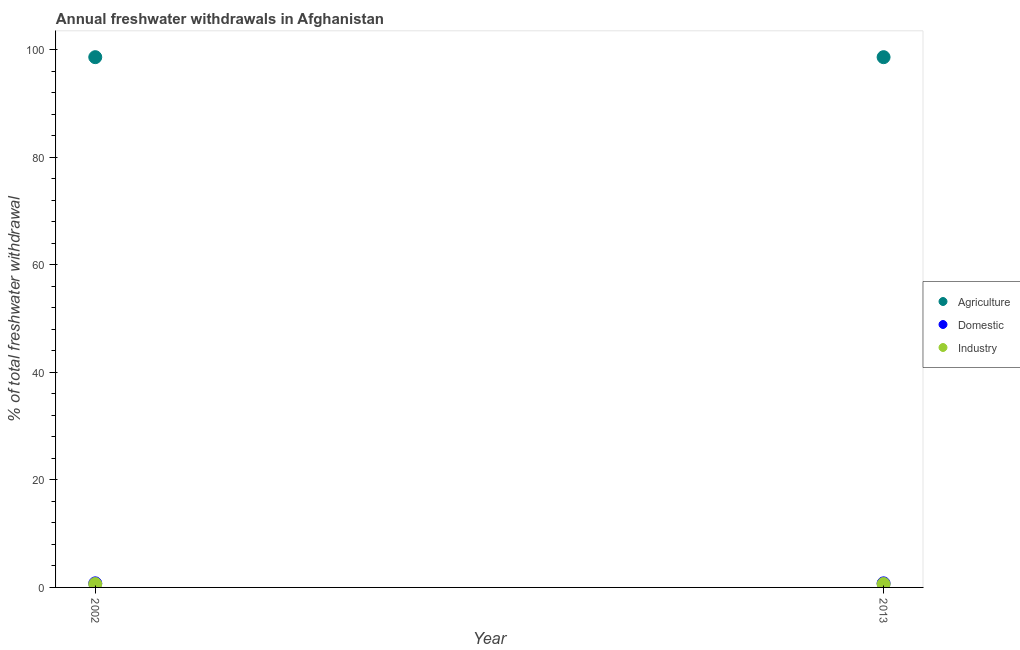Is the number of dotlines equal to the number of legend labels?
Your response must be concise. Yes. What is the percentage of freshwater withdrawal for domestic purposes in 2013?
Make the answer very short. 0.76. Across all years, what is the maximum percentage of freshwater withdrawal for domestic purposes?
Offer a terse response. 0.76. Across all years, what is the minimum percentage of freshwater withdrawal for industry?
Provide a short and direct response. 0.63. What is the total percentage of freshwater withdrawal for domestic purposes in the graph?
Offer a terse response. 1.52. What is the difference between the percentage of freshwater withdrawal for domestic purposes in 2002 and that in 2013?
Keep it short and to the point. 0. What is the difference between the percentage of freshwater withdrawal for domestic purposes in 2013 and the percentage of freshwater withdrawal for agriculture in 2002?
Offer a terse response. -97.86. What is the average percentage of freshwater withdrawal for agriculture per year?
Your answer should be compact. 98.62. In the year 2013, what is the difference between the percentage of freshwater withdrawal for industry and percentage of freshwater withdrawal for domestic purposes?
Offer a very short reply. -0.13. What is the ratio of the percentage of freshwater withdrawal for domestic purposes in 2002 to that in 2013?
Offer a terse response. 1. Is the percentage of freshwater withdrawal for agriculture in 2002 less than that in 2013?
Offer a very short reply. No. In how many years, is the percentage of freshwater withdrawal for agriculture greater than the average percentage of freshwater withdrawal for agriculture taken over all years?
Offer a terse response. 0. Is it the case that in every year, the sum of the percentage of freshwater withdrawal for agriculture and percentage of freshwater withdrawal for domestic purposes is greater than the percentage of freshwater withdrawal for industry?
Your answer should be very brief. Yes. Does the percentage of freshwater withdrawal for industry monotonically increase over the years?
Your answer should be compact. No. Is the percentage of freshwater withdrawal for agriculture strictly greater than the percentage of freshwater withdrawal for domestic purposes over the years?
Make the answer very short. Yes. Is the percentage of freshwater withdrawal for domestic purposes strictly less than the percentage of freshwater withdrawal for industry over the years?
Your answer should be compact. No. How many dotlines are there?
Give a very brief answer. 3. How many years are there in the graph?
Offer a very short reply. 2. What is the difference between two consecutive major ticks on the Y-axis?
Your answer should be compact. 20. Where does the legend appear in the graph?
Make the answer very short. Center right. How are the legend labels stacked?
Your response must be concise. Vertical. What is the title of the graph?
Offer a very short reply. Annual freshwater withdrawals in Afghanistan. Does "New Zealand" appear as one of the legend labels in the graph?
Offer a terse response. No. What is the label or title of the Y-axis?
Make the answer very short. % of total freshwater withdrawal. What is the % of total freshwater withdrawal in Agriculture in 2002?
Your answer should be very brief. 98.62. What is the % of total freshwater withdrawal in Domestic in 2002?
Keep it short and to the point. 0.76. What is the % of total freshwater withdrawal in Industry in 2002?
Your answer should be compact. 0.63. What is the % of total freshwater withdrawal in Agriculture in 2013?
Provide a short and direct response. 98.62. What is the % of total freshwater withdrawal in Domestic in 2013?
Ensure brevity in your answer.  0.76. What is the % of total freshwater withdrawal in Industry in 2013?
Give a very brief answer. 0.63. Across all years, what is the maximum % of total freshwater withdrawal in Agriculture?
Keep it short and to the point. 98.62. Across all years, what is the maximum % of total freshwater withdrawal in Domestic?
Make the answer very short. 0.76. Across all years, what is the maximum % of total freshwater withdrawal of Industry?
Your response must be concise. 0.63. Across all years, what is the minimum % of total freshwater withdrawal in Agriculture?
Your response must be concise. 98.62. Across all years, what is the minimum % of total freshwater withdrawal in Domestic?
Offer a very short reply. 0.76. Across all years, what is the minimum % of total freshwater withdrawal of Industry?
Your response must be concise. 0.63. What is the total % of total freshwater withdrawal of Agriculture in the graph?
Offer a very short reply. 197.24. What is the total % of total freshwater withdrawal in Domestic in the graph?
Offer a very short reply. 1.52. What is the total % of total freshwater withdrawal in Industry in the graph?
Your answer should be compact. 1.27. What is the difference between the % of total freshwater withdrawal of Domestic in 2002 and that in 2013?
Your answer should be very brief. 0. What is the difference between the % of total freshwater withdrawal of Agriculture in 2002 and the % of total freshwater withdrawal of Domestic in 2013?
Your answer should be very brief. 97.86. What is the difference between the % of total freshwater withdrawal in Agriculture in 2002 and the % of total freshwater withdrawal in Industry in 2013?
Provide a short and direct response. 97.99. What is the difference between the % of total freshwater withdrawal of Domestic in 2002 and the % of total freshwater withdrawal of Industry in 2013?
Your answer should be compact. 0.13. What is the average % of total freshwater withdrawal in Agriculture per year?
Your response must be concise. 98.62. What is the average % of total freshwater withdrawal of Domestic per year?
Your answer should be compact. 0.76. What is the average % of total freshwater withdrawal of Industry per year?
Offer a terse response. 0.63. In the year 2002, what is the difference between the % of total freshwater withdrawal in Agriculture and % of total freshwater withdrawal in Domestic?
Your response must be concise. 97.86. In the year 2002, what is the difference between the % of total freshwater withdrawal in Agriculture and % of total freshwater withdrawal in Industry?
Keep it short and to the point. 97.99. In the year 2002, what is the difference between the % of total freshwater withdrawal in Domestic and % of total freshwater withdrawal in Industry?
Your answer should be compact. 0.13. In the year 2013, what is the difference between the % of total freshwater withdrawal of Agriculture and % of total freshwater withdrawal of Domestic?
Keep it short and to the point. 97.86. In the year 2013, what is the difference between the % of total freshwater withdrawal in Agriculture and % of total freshwater withdrawal in Industry?
Provide a short and direct response. 97.99. In the year 2013, what is the difference between the % of total freshwater withdrawal in Domestic and % of total freshwater withdrawal in Industry?
Keep it short and to the point. 0.13. What is the ratio of the % of total freshwater withdrawal of Agriculture in 2002 to that in 2013?
Offer a terse response. 1. What is the ratio of the % of total freshwater withdrawal in Domestic in 2002 to that in 2013?
Make the answer very short. 1. What is the difference between the highest and the second highest % of total freshwater withdrawal in Domestic?
Give a very brief answer. 0. What is the difference between the highest and the lowest % of total freshwater withdrawal in Agriculture?
Your response must be concise. 0. 